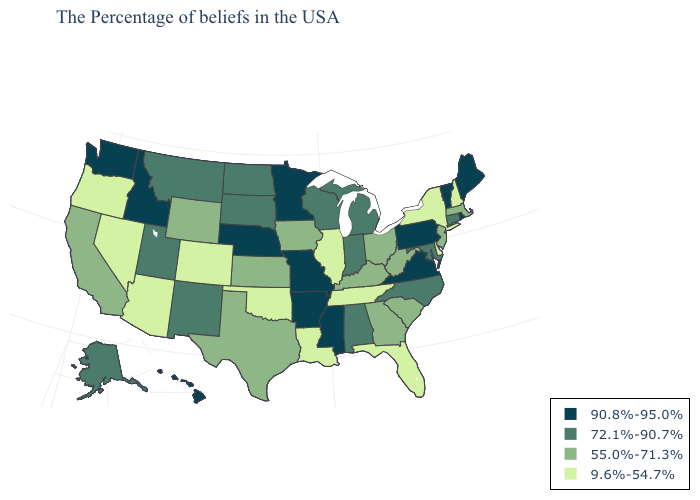Does Nebraska have the highest value in the MidWest?
Concise answer only. Yes. Name the states that have a value in the range 90.8%-95.0%?
Keep it brief. Maine, Rhode Island, Vermont, Pennsylvania, Virginia, Mississippi, Missouri, Arkansas, Minnesota, Nebraska, Idaho, Washington, Hawaii. Does Indiana have the lowest value in the USA?
Quick response, please. No. Name the states that have a value in the range 9.6%-54.7%?
Concise answer only. New Hampshire, New York, Delaware, Florida, Tennessee, Illinois, Louisiana, Oklahoma, Colorado, Arizona, Nevada, Oregon. Which states hav the highest value in the Northeast?
Be succinct. Maine, Rhode Island, Vermont, Pennsylvania. What is the value of Rhode Island?
Short answer required. 90.8%-95.0%. What is the highest value in the USA?
Short answer required. 90.8%-95.0%. Is the legend a continuous bar?
Be succinct. No. What is the highest value in the South ?
Keep it brief. 90.8%-95.0%. Does Colorado have a higher value than Vermont?
Be succinct. No. What is the value of West Virginia?
Keep it brief. 55.0%-71.3%. Name the states that have a value in the range 90.8%-95.0%?
Answer briefly. Maine, Rhode Island, Vermont, Pennsylvania, Virginia, Mississippi, Missouri, Arkansas, Minnesota, Nebraska, Idaho, Washington, Hawaii. What is the highest value in states that border Illinois?
Quick response, please. 90.8%-95.0%. Does Minnesota have the highest value in the MidWest?
Write a very short answer. Yes. 